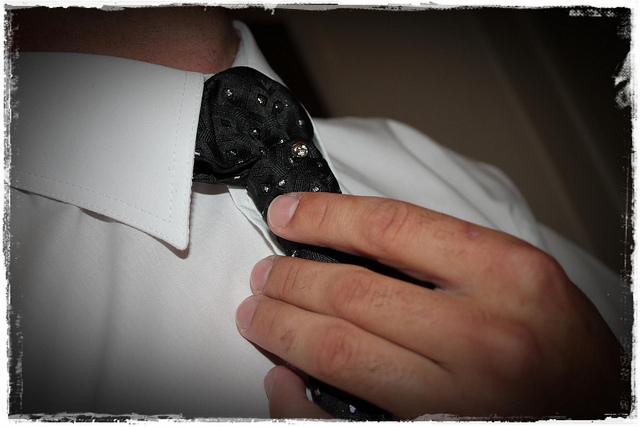What is the man holding on to?
Answer briefly. Tie. What type of knot is the tie?
Give a very brief answer. Windsor. What color is the man's shirt?
Be succinct. White. 